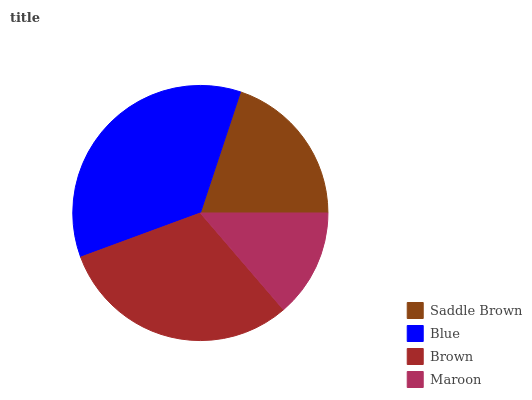Is Maroon the minimum?
Answer yes or no. Yes. Is Blue the maximum?
Answer yes or no. Yes. Is Brown the minimum?
Answer yes or no. No. Is Brown the maximum?
Answer yes or no. No. Is Blue greater than Brown?
Answer yes or no. Yes. Is Brown less than Blue?
Answer yes or no. Yes. Is Brown greater than Blue?
Answer yes or no. No. Is Blue less than Brown?
Answer yes or no. No. Is Brown the high median?
Answer yes or no. Yes. Is Saddle Brown the low median?
Answer yes or no. Yes. Is Blue the high median?
Answer yes or no. No. Is Maroon the low median?
Answer yes or no. No. 